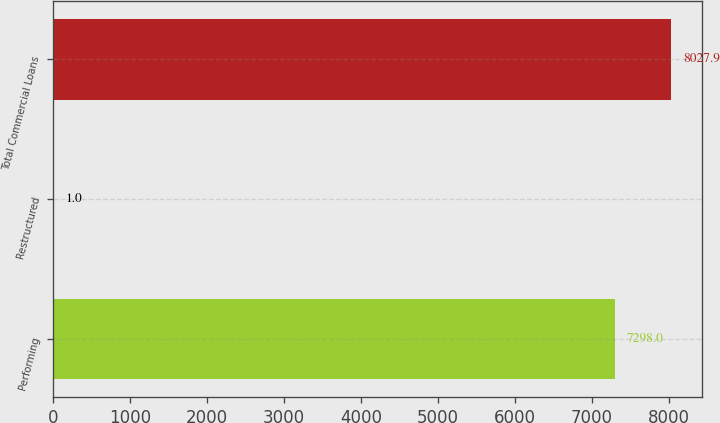<chart> <loc_0><loc_0><loc_500><loc_500><bar_chart><fcel>Performing<fcel>Restructured<fcel>Total Commercial Loans<nl><fcel>7298<fcel>1<fcel>8027.9<nl></chart> 